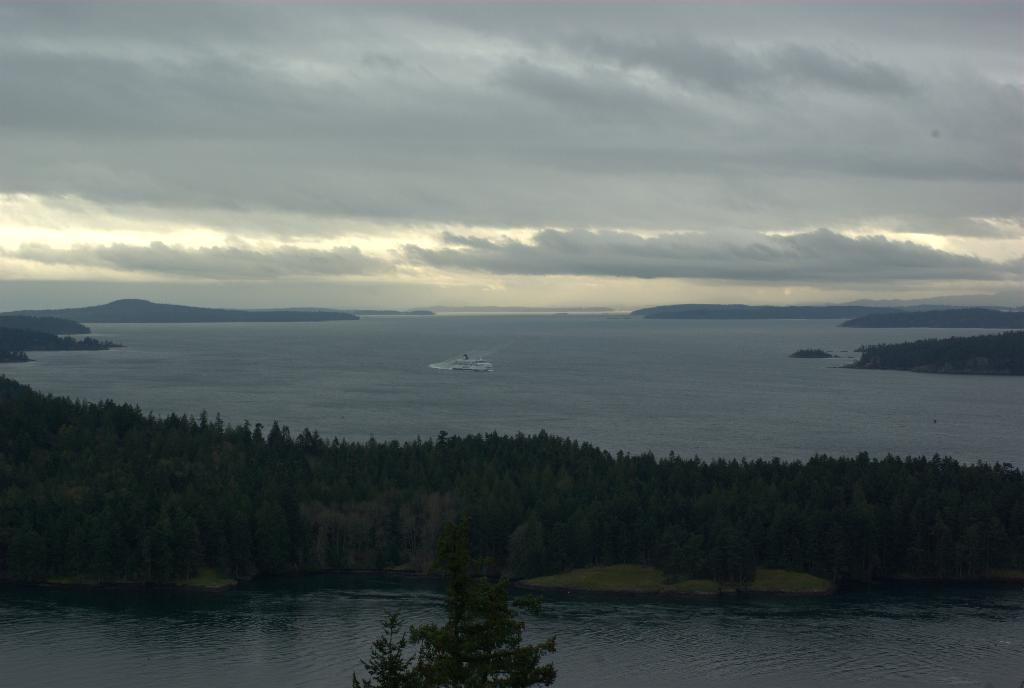What is located at the front of the image? There is water in the front of the image. What can be seen in the center of the image? There are trees in the center of the image. What is on the water in the image? There is a ship on the water. What is visible at the back of the image? There are mountains at the back of the image. What is present in the sky in the image? There are clouds in the sky. How many brothers are on the ship in the image? There is no mention of brothers in the image, and no indication of people on the ship. What type of beam is holding up the mountains in the image? There is no beam present in the image; the mountains are a natural formation. 